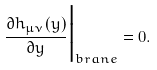Convert formula to latex. <formula><loc_0><loc_0><loc_500><loc_500>\frac { \partial h _ { \mu \nu } ( y ) } { \partial y } \Big { | } _ { b r a n e } = 0 .</formula> 